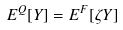Convert formula to latex. <formula><loc_0><loc_0><loc_500><loc_500>E ^ { Q } [ Y ] = E ^ { F } [ \zeta Y ]</formula> 